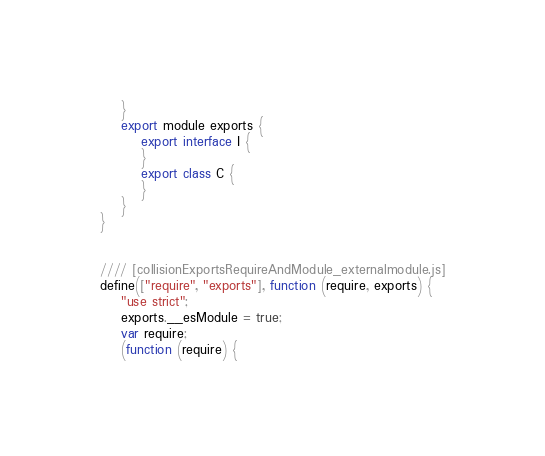Convert code to text. <code><loc_0><loc_0><loc_500><loc_500><_JavaScript_>    }
    export module exports {
        export interface I {
        }
        export class C {
        }
    }
}


//// [collisionExportsRequireAndModule_externalmodule.js]
define(["require", "exports"], function (require, exports) {
    "use strict";
    exports.__esModule = true;
    var require;
    (function (require) {</code> 